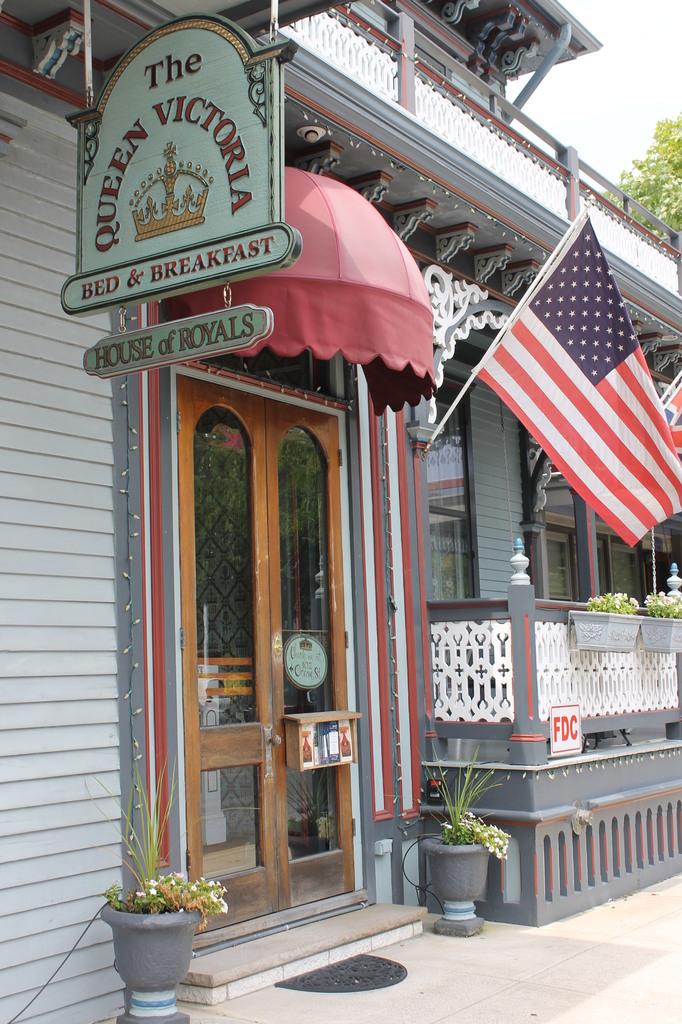What type of establishment is this?
Your answer should be very brief. Bed and breakfast. 